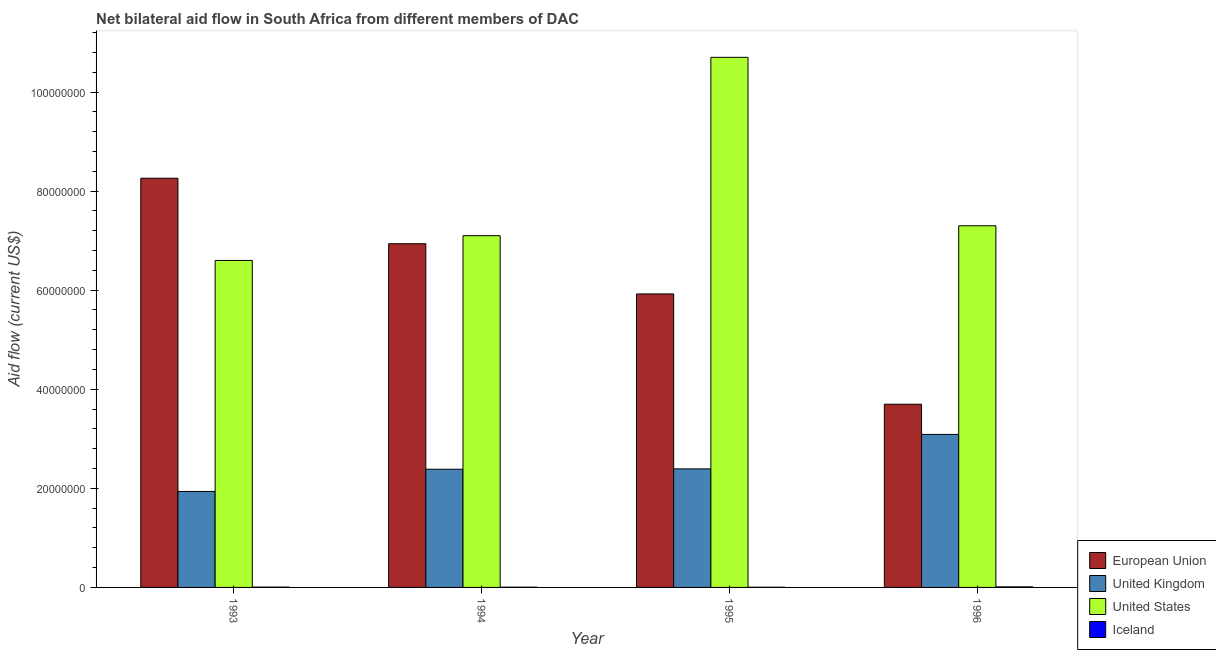How many different coloured bars are there?
Your response must be concise. 4. Are the number of bars per tick equal to the number of legend labels?
Offer a very short reply. Yes. How many bars are there on the 2nd tick from the left?
Your answer should be very brief. 4. How many bars are there on the 1st tick from the right?
Give a very brief answer. 4. In how many cases, is the number of bars for a given year not equal to the number of legend labels?
Provide a succinct answer. 0. What is the amount of aid given by eu in 1995?
Give a very brief answer. 5.92e+07. Across all years, what is the maximum amount of aid given by us?
Ensure brevity in your answer.  1.07e+08. Across all years, what is the minimum amount of aid given by uk?
Your response must be concise. 1.94e+07. In which year was the amount of aid given by eu minimum?
Your answer should be compact. 1996. What is the total amount of aid given by us in the graph?
Your answer should be compact. 3.17e+08. What is the difference between the amount of aid given by uk in 1995 and that in 1996?
Provide a succinct answer. -6.96e+06. What is the difference between the amount of aid given by us in 1994 and the amount of aid given by iceland in 1996?
Keep it short and to the point. -2.00e+06. What is the average amount of aid given by uk per year?
Your response must be concise. 2.45e+07. What is the ratio of the amount of aid given by us in 1993 to that in 1995?
Provide a short and direct response. 0.62. Is the difference between the amount of aid given by uk in 1993 and 1996 greater than the difference between the amount of aid given by iceland in 1993 and 1996?
Your answer should be compact. No. What is the difference between the highest and the second highest amount of aid given by us?
Your response must be concise. 3.40e+07. What is the difference between the highest and the lowest amount of aid given by iceland?
Provide a short and direct response. 7.00e+04. In how many years, is the amount of aid given by us greater than the average amount of aid given by us taken over all years?
Offer a very short reply. 1. Is the sum of the amount of aid given by uk in 1993 and 1994 greater than the maximum amount of aid given by us across all years?
Provide a short and direct response. Yes. What does the 1st bar from the left in 1996 represents?
Provide a short and direct response. European Union. What does the 3rd bar from the right in 1995 represents?
Your answer should be compact. United Kingdom. Are all the bars in the graph horizontal?
Ensure brevity in your answer.  No. How many years are there in the graph?
Keep it short and to the point. 4. What is the difference between two consecutive major ticks on the Y-axis?
Keep it short and to the point. 2.00e+07. Are the values on the major ticks of Y-axis written in scientific E-notation?
Your answer should be very brief. No. How are the legend labels stacked?
Your response must be concise. Vertical. What is the title of the graph?
Offer a very short reply. Net bilateral aid flow in South Africa from different members of DAC. What is the label or title of the X-axis?
Offer a very short reply. Year. What is the Aid flow (current US$) of European Union in 1993?
Offer a very short reply. 8.26e+07. What is the Aid flow (current US$) of United Kingdom in 1993?
Your answer should be very brief. 1.94e+07. What is the Aid flow (current US$) in United States in 1993?
Provide a succinct answer. 6.60e+07. What is the Aid flow (current US$) of European Union in 1994?
Your response must be concise. 6.94e+07. What is the Aid flow (current US$) in United Kingdom in 1994?
Keep it short and to the point. 2.39e+07. What is the Aid flow (current US$) of United States in 1994?
Make the answer very short. 7.10e+07. What is the Aid flow (current US$) of Iceland in 1994?
Your answer should be compact. 5.00e+04. What is the Aid flow (current US$) of European Union in 1995?
Give a very brief answer. 5.92e+07. What is the Aid flow (current US$) in United Kingdom in 1995?
Your response must be concise. 2.39e+07. What is the Aid flow (current US$) of United States in 1995?
Keep it short and to the point. 1.07e+08. What is the Aid flow (current US$) of Iceland in 1995?
Your answer should be very brief. 4.00e+04. What is the Aid flow (current US$) of European Union in 1996?
Your answer should be compact. 3.70e+07. What is the Aid flow (current US$) of United Kingdom in 1996?
Keep it short and to the point. 3.09e+07. What is the Aid flow (current US$) in United States in 1996?
Offer a terse response. 7.30e+07. Across all years, what is the maximum Aid flow (current US$) in European Union?
Offer a very short reply. 8.26e+07. Across all years, what is the maximum Aid flow (current US$) in United Kingdom?
Offer a terse response. 3.09e+07. Across all years, what is the maximum Aid flow (current US$) of United States?
Offer a very short reply. 1.07e+08. Across all years, what is the maximum Aid flow (current US$) of Iceland?
Make the answer very short. 1.10e+05. Across all years, what is the minimum Aid flow (current US$) of European Union?
Offer a terse response. 3.70e+07. Across all years, what is the minimum Aid flow (current US$) in United Kingdom?
Ensure brevity in your answer.  1.94e+07. Across all years, what is the minimum Aid flow (current US$) in United States?
Keep it short and to the point. 6.60e+07. Across all years, what is the minimum Aid flow (current US$) of Iceland?
Make the answer very short. 4.00e+04. What is the total Aid flow (current US$) in European Union in the graph?
Ensure brevity in your answer.  2.48e+08. What is the total Aid flow (current US$) of United Kingdom in the graph?
Ensure brevity in your answer.  9.80e+07. What is the total Aid flow (current US$) in United States in the graph?
Offer a very short reply. 3.17e+08. What is the difference between the Aid flow (current US$) of European Union in 1993 and that in 1994?
Offer a terse response. 1.32e+07. What is the difference between the Aid flow (current US$) in United Kingdom in 1993 and that in 1994?
Offer a very short reply. -4.49e+06. What is the difference between the Aid flow (current US$) in United States in 1993 and that in 1994?
Your answer should be compact. -5.00e+06. What is the difference between the Aid flow (current US$) in Iceland in 1993 and that in 1994?
Offer a terse response. 2.00e+04. What is the difference between the Aid flow (current US$) of European Union in 1993 and that in 1995?
Give a very brief answer. 2.34e+07. What is the difference between the Aid flow (current US$) of United Kingdom in 1993 and that in 1995?
Ensure brevity in your answer.  -4.56e+06. What is the difference between the Aid flow (current US$) of United States in 1993 and that in 1995?
Give a very brief answer. -4.10e+07. What is the difference between the Aid flow (current US$) in Iceland in 1993 and that in 1995?
Keep it short and to the point. 3.00e+04. What is the difference between the Aid flow (current US$) in European Union in 1993 and that in 1996?
Your answer should be very brief. 4.56e+07. What is the difference between the Aid flow (current US$) of United Kingdom in 1993 and that in 1996?
Provide a short and direct response. -1.15e+07. What is the difference between the Aid flow (current US$) of United States in 1993 and that in 1996?
Provide a succinct answer. -7.00e+06. What is the difference between the Aid flow (current US$) of European Union in 1994 and that in 1995?
Make the answer very short. 1.01e+07. What is the difference between the Aid flow (current US$) in United Kingdom in 1994 and that in 1995?
Provide a short and direct response. -7.00e+04. What is the difference between the Aid flow (current US$) in United States in 1994 and that in 1995?
Provide a succinct answer. -3.60e+07. What is the difference between the Aid flow (current US$) of Iceland in 1994 and that in 1995?
Your response must be concise. 10000. What is the difference between the Aid flow (current US$) in European Union in 1994 and that in 1996?
Give a very brief answer. 3.24e+07. What is the difference between the Aid flow (current US$) of United Kingdom in 1994 and that in 1996?
Provide a succinct answer. -7.03e+06. What is the difference between the Aid flow (current US$) in Iceland in 1994 and that in 1996?
Offer a very short reply. -6.00e+04. What is the difference between the Aid flow (current US$) of European Union in 1995 and that in 1996?
Offer a terse response. 2.23e+07. What is the difference between the Aid flow (current US$) of United Kingdom in 1995 and that in 1996?
Offer a very short reply. -6.96e+06. What is the difference between the Aid flow (current US$) in United States in 1995 and that in 1996?
Your answer should be very brief. 3.40e+07. What is the difference between the Aid flow (current US$) of European Union in 1993 and the Aid flow (current US$) of United Kingdom in 1994?
Your response must be concise. 5.87e+07. What is the difference between the Aid flow (current US$) in European Union in 1993 and the Aid flow (current US$) in United States in 1994?
Offer a very short reply. 1.16e+07. What is the difference between the Aid flow (current US$) of European Union in 1993 and the Aid flow (current US$) of Iceland in 1994?
Your response must be concise. 8.26e+07. What is the difference between the Aid flow (current US$) of United Kingdom in 1993 and the Aid flow (current US$) of United States in 1994?
Offer a terse response. -5.16e+07. What is the difference between the Aid flow (current US$) in United Kingdom in 1993 and the Aid flow (current US$) in Iceland in 1994?
Your answer should be compact. 1.93e+07. What is the difference between the Aid flow (current US$) of United States in 1993 and the Aid flow (current US$) of Iceland in 1994?
Your answer should be very brief. 6.60e+07. What is the difference between the Aid flow (current US$) of European Union in 1993 and the Aid flow (current US$) of United Kingdom in 1995?
Ensure brevity in your answer.  5.87e+07. What is the difference between the Aid flow (current US$) of European Union in 1993 and the Aid flow (current US$) of United States in 1995?
Your response must be concise. -2.44e+07. What is the difference between the Aid flow (current US$) of European Union in 1993 and the Aid flow (current US$) of Iceland in 1995?
Keep it short and to the point. 8.26e+07. What is the difference between the Aid flow (current US$) in United Kingdom in 1993 and the Aid flow (current US$) in United States in 1995?
Your answer should be very brief. -8.76e+07. What is the difference between the Aid flow (current US$) of United Kingdom in 1993 and the Aid flow (current US$) of Iceland in 1995?
Give a very brief answer. 1.93e+07. What is the difference between the Aid flow (current US$) of United States in 1993 and the Aid flow (current US$) of Iceland in 1995?
Make the answer very short. 6.60e+07. What is the difference between the Aid flow (current US$) in European Union in 1993 and the Aid flow (current US$) in United Kingdom in 1996?
Provide a short and direct response. 5.17e+07. What is the difference between the Aid flow (current US$) in European Union in 1993 and the Aid flow (current US$) in United States in 1996?
Keep it short and to the point. 9.60e+06. What is the difference between the Aid flow (current US$) of European Union in 1993 and the Aid flow (current US$) of Iceland in 1996?
Offer a terse response. 8.25e+07. What is the difference between the Aid flow (current US$) in United Kingdom in 1993 and the Aid flow (current US$) in United States in 1996?
Ensure brevity in your answer.  -5.36e+07. What is the difference between the Aid flow (current US$) in United Kingdom in 1993 and the Aid flow (current US$) in Iceland in 1996?
Keep it short and to the point. 1.93e+07. What is the difference between the Aid flow (current US$) in United States in 1993 and the Aid flow (current US$) in Iceland in 1996?
Your response must be concise. 6.59e+07. What is the difference between the Aid flow (current US$) in European Union in 1994 and the Aid flow (current US$) in United Kingdom in 1995?
Offer a very short reply. 4.54e+07. What is the difference between the Aid flow (current US$) in European Union in 1994 and the Aid flow (current US$) in United States in 1995?
Provide a succinct answer. -3.76e+07. What is the difference between the Aid flow (current US$) of European Union in 1994 and the Aid flow (current US$) of Iceland in 1995?
Keep it short and to the point. 6.93e+07. What is the difference between the Aid flow (current US$) in United Kingdom in 1994 and the Aid flow (current US$) in United States in 1995?
Provide a short and direct response. -8.31e+07. What is the difference between the Aid flow (current US$) in United Kingdom in 1994 and the Aid flow (current US$) in Iceland in 1995?
Your answer should be compact. 2.38e+07. What is the difference between the Aid flow (current US$) of United States in 1994 and the Aid flow (current US$) of Iceland in 1995?
Offer a terse response. 7.10e+07. What is the difference between the Aid flow (current US$) in European Union in 1994 and the Aid flow (current US$) in United Kingdom in 1996?
Offer a very short reply. 3.85e+07. What is the difference between the Aid flow (current US$) in European Union in 1994 and the Aid flow (current US$) in United States in 1996?
Keep it short and to the point. -3.62e+06. What is the difference between the Aid flow (current US$) in European Union in 1994 and the Aid flow (current US$) in Iceland in 1996?
Offer a very short reply. 6.93e+07. What is the difference between the Aid flow (current US$) in United Kingdom in 1994 and the Aid flow (current US$) in United States in 1996?
Give a very brief answer. -4.91e+07. What is the difference between the Aid flow (current US$) of United Kingdom in 1994 and the Aid flow (current US$) of Iceland in 1996?
Keep it short and to the point. 2.38e+07. What is the difference between the Aid flow (current US$) in United States in 1994 and the Aid flow (current US$) in Iceland in 1996?
Your answer should be very brief. 7.09e+07. What is the difference between the Aid flow (current US$) of European Union in 1995 and the Aid flow (current US$) of United Kingdom in 1996?
Your answer should be very brief. 2.84e+07. What is the difference between the Aid flow (current US$) of European Union in 1995 and the Aid flow (current US$) of United States in 1996?
Your answer should be very brief. -1.38e+07. What is the difference between the Aid flow (current US$) in European Union in 1995 and the Aid flow (current US$) in Iceland in 1996?
Your answer should be very brief. 5.91e+07. What is the difference between the Aid flow (current US$) in United Kingdom in 1995 and the Aid flow (current US$) in United States in 1996?
Give a very brief answer. -4.91e+07. What is the difference between the Aid flow (current US$) in United Kingdom in 1995 and the Aid flow (current US$) in Iceland in 1996?
Provide a succinct answer. 2.38e+07. What is the difference between the Aid flow (current US$) of United States in 1995 and the Aid flow (current US$) of Iceland in 1996?
Provide a succinct answer. 1.07e+08. What is the average Aid flow (current US$) of European Union per year?
Your response must be concise. 6.20e+07. What is the average Aid flow (current US$) of United Kingdom per year?
Provide a succinct answer. 2.45e+07. What is the average Aid flow (current US$) of United States per year?
Keep it short and to the point. 7.92e+07. What is the average Aid flow (current US$) in Iceland per year?
Offer a terse response. 6.75e+04. In the year 1993, what is the difference between the Aid flow (current US$) of European Union and Aid flow (current US$) of United Kingdom?
Offer a terse response. 6.32e+07. In the year 1993, what is the difference between the Aid flow (current US$) of European Union and Aid flow (current US$) of United States?
Offer a very short reply. 1.66e+07. In the year 1993, what is the difference between the Aid flow (current US$) of European Union and Aid flow (current US$) of Iceland?
Make the answer very short. 8.25e+07. In the year 1993, what is the difference between the Aid flow (current US$) of United Kingdom and Aid flow (current US$) of United States?
Offer a very short reply. -4.66e+07. In the year 1993, what is the difference between the Aid flow (current US$) in United Kingdom and Aid flow (current US$) in Iceland?
Offer a terse response. 1.93e+07. In the year 1993, what is the difference between the Aid flow (current US$) in United States and Aid flow (current US$) in Iceland?
Offer a terse response. 6.59e+07. In the year 1994, what is the difference between the Aid flow (current US$) in European Union and Aid flow (current US$) in United Kingdom?
Provide a short and direct response. 4.55e+07. In the year 1994, what is the difference between the Aid flow (current US$) of European Union and Aid flow (current US$) of United States?
Your response must be concise. -1.62e+06. In the year 1994, what is the difference between the Aid flow (current US$) of European Union and Aid flow (current US$) of Iceland?
Provide a short and direct response. 6.93e+07. In the year 1994, what is the difference between the Aid flow (current US$) in United Kingdom and Aid flow (current US$) in United States?
Make the answer very short. -4.71e+07. In the year 1994, what is the difference between the Aid flow (current US$) in United Kingdom and Aid flow (current US$) in Iceland?
Offer a terse response. 2.38e+07. In the year 1994, what is the difference between the Aid flow (current US$) in United States and Aid flow (current US$) in Iceland?
Offer a very short reply. 7.10e+07. In the year 1995, what is the difference between the Aid flow (current US$) in European Union and Aid flow (current US$) in United Kingdom?
Your answer should be compact. 3.53e+07. In the year 1995, what is the difference between the Aid flow (current US$) in European Union and Aid flow (current US$) in United States?
Offer a very short reply. -4.78e+07. In the year 1995, what is the difference between the Aid flow (current US$) of European Union and Aid flow (current US$) of Iceland?
Offer a very short reply. 5.92e+07. In the year 1995, what is the difference between the Aid flow (current US$) of United Kingdom and Aid flow (current US$) of United States?
Keep it short and to the point. -8.31e+07. In the year 1995, what is the difference between the Aid flow (current US$) of United Kingdom and Aid flow (current US$) of Iceland?
Offer a terse response. 2.39e+07. In the year 1995, what is the difference between the Aid flow (current US$) of United States and Aid flow (current US$) of Iceland?
Your answer should be compact. 1.07e+08. In the year 1996, what is the difference between the Aid flow (current US$) in European Union and Aid flow (current US$) in United Kingdom?
Make the answer very short. 6.09e+06. In the year 1996, what is the difference between the Aid flow (current US$) in European Union and Aid flow (current US$) in United States?
Give a very brief answer. -3.60e+07. In the year 1996, what is the difference between the Aid flow (current US$) in European Union and Aid flow (current US$) in Iceland?
Your response must be concise. 3.69e+07. In the year 1996, what is the difference between the Aid flow (current US$) in United Kingdom and Aid flow (current US$) in United States?
Give a very brief answer. -4.21e+07. In the year 1996, what is the difference between the Aid flow (current US$) of United Kingdom and Aid flow (current US$) of Iceland?
Your response must be concise. 3.08e+07. In the year 1996, what is the difference between the Aid flow (current US$) in United States and Aid flow (current US$) in Iceland?
Provide a succinct answer. 7.29e+07. What is the ratio of the Aid flow (current US$) in European Union in 1993 to that in 1994?
Your answer should be very brief. 1.19. What is the ratio of the Aid flow (current US$) of United Kingdom in 1993 to that in 1994?
Your response must be concise. 0.81. What is the ratio of the Aid flow (current US$) in United States in 1993 to that in 1994?
Make the answer very short. 0.93. What is the ratio of the Aid flow (current US$) of European Union in 1993 to that in 1995?
Make the answer very short. 1.39. What is the ratio of the Aid flow (current US$) in United Kingdom in 1993 to that in 1995?
Give a very brief answer. 0.81. What is the ratio of the Aid flow (current US$) in United States in 1993 to that in 1995?
Give a very brief answer. 0.62. What is the ratio of the Aid flow (current US$) of European Union in 1993 to that in 1996?
Offer a terse response. 2.23. What is the ratio of the Aid flow (current US$) of United Kingdom in 1993 to that in 1996?
Provide a succinct answer. 0.63. What is the ratio of the Aid flow (current US$) of United States in 1993 to that in 1996?
Provide a succinct answer. 0.9. What is the ratio of the Aid flow (current US$) of Iceland in 1993 to that in 1996?
Provide a short and direct response. 0.64. What is the ratio of the Aid flow (current US$) in European Union in 1994 to that in 1995?
Make the answer very short. 1.17. What is the ratio of the Aid flow (current US$) in United States in 1994 to that in 1995?
Give a very brief answer. 0.66. What is the ratio of the Aid flow (current US$) in Iceland in 1994 to that in 1995?
Your answer should be compact. 1.25. What is the ratio of the Aid flow (current US$) of European Union in 1994 to that in 1996?
Give a very brief answer. 1.88. What is the ratio of the Aid flow (current US$) of United Kingdom in 1994 to that in 1996?
Make the answer very short. 0.77. What is the ratio of the Aid flow (current US$) in United States in 1994 to that in 1996?
Offer a very short reply. 0.97. What is the ratio of the Aid flow (current US$) in Iceland in 1994 to that in 1996?
Provide a succinct answer. 0.45. What is the ratio of the Aid flow (current US$) of European Union in 1995 to that in 1996?
Provide a short and direct response. 1.6. What is the ratio of the Aid flow (current US$) in United Kingdom in 1995 to that in 1996?
Your answer should be compact. 0.77. What is the ratio of the Aid flow (current US$) of United States in 1995 to that in 1996?
Your answer should be very brief. 1.47. What is the ratio of the Aid flow (current US$) in Iceland in 1995 to that in 1996?
Give a very brief answer. 0.36. What is the difference between the highest and the second highest Aid flow (current US$) of European Union?
Ensure brevity in your answer.  1.32e+07. What is the difference between the highest and the second highest Aid flow (current US$) of United Kingdom?
Ensure brevity in your answer.  6.96e+06. What is the difference between the highest and the second highest Aid flow (current US$) in United States?
Provide a succinct answer. 3.40e+07. What is the difference between the highest and the lowest Aid flow (current US$) of European Union?
Your response must be concise. 4.56e+07. What is the difference between the highest and the lowest Aid flow (current US$) of United Kingdom?
Offer a terse response. 1.15e+07. What is the difference between the highest and the lowest Aid flow (current US$) in United States?
Ensure brevity in your answer.  4.10e+07. What is the difference between the highest and the lowest Aid flow (current US$) of Iceland?
Make the answer very short. 7.00e+04. 